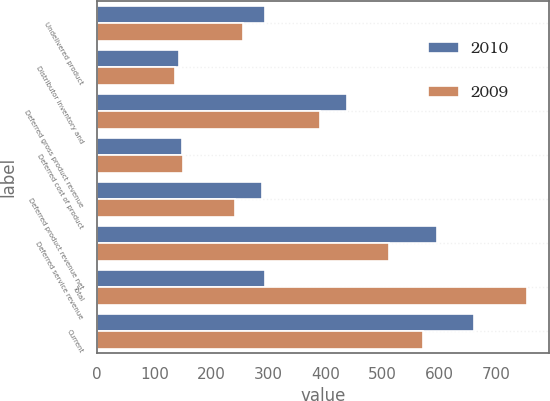Convert chart to OTSL. <chart><loc_0><loc_0><loc_500><loc_500><stacked_bar_chart><ecel><fcel>Undelivered product<fcel>Distributor inventory and<fcel>Deferred gross product revenue<fcel>Deferred cost of product<fcel>Deferred product revenue net<fcel>Deferred service revenue<fcel>Total<fcel>Current<nl><fcel>2010<fcel>294.1<fcel>143.4<fcel>437.5<fcel>148.8<fcel>288.7<fcel>595.7<fcel>294.1<fcel>660.2<nl><fcel>2009<fcel>254.7<fcel>136.6<fcel>391.3<fcel>150<fcel>241.3<fcel>512.3<fcel>753.6<fcel>571.7<nl></chart> 